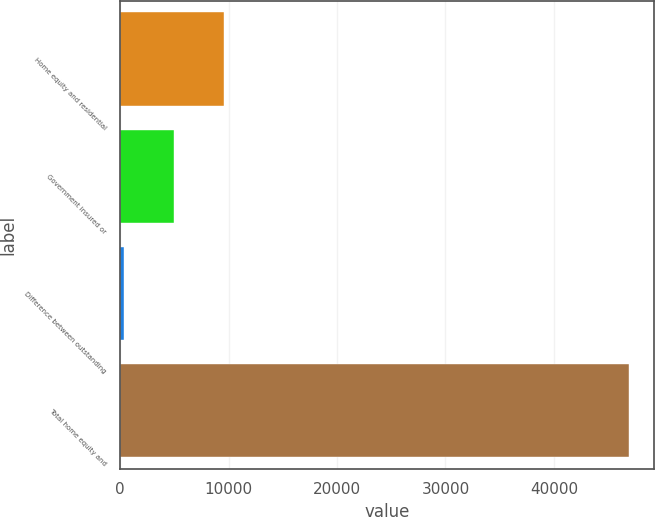<chart> <loc_0><loc_0><loc_500><loc_500><bar_chart><fcel>Home equity and residential<fcel>Government insured or<fcel>Difference between outstanding<fcel>Total home equity and<nl><fcel>9573.6<fcel>4952.3<fcel>331<fcel>46889.3<nl></chart> 